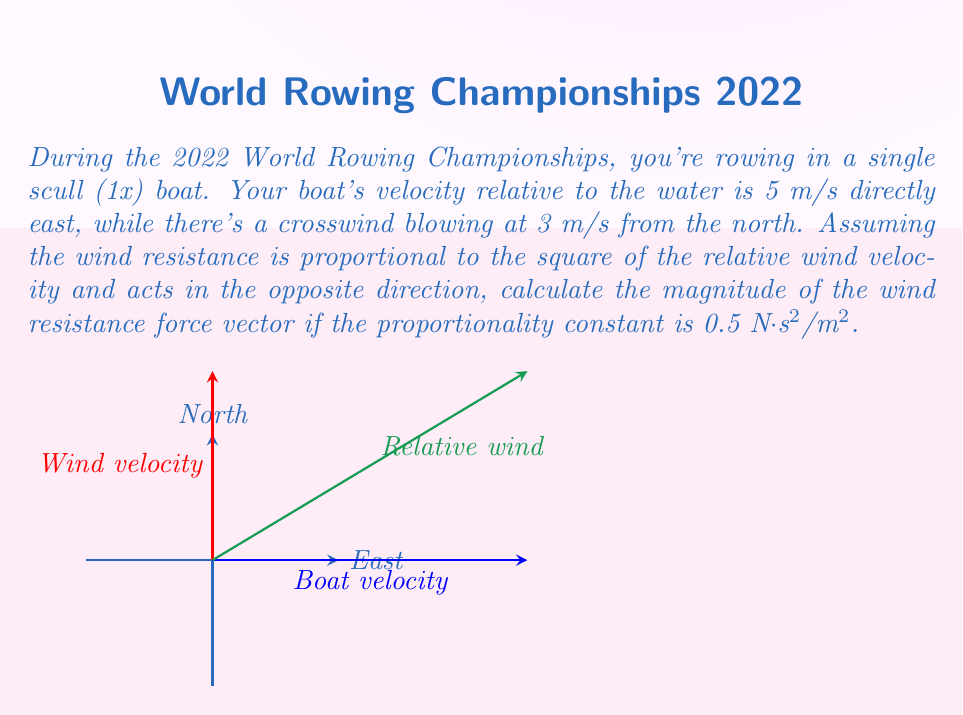Provide a solution to this math problem. Let's approach this step-by-step:

1) First, we need to find the relative wind velocity vector. This is the vector sum of the boat's velocity and the wind velocity:

   $\vec{v}_{rel} = \vec{v}_{boat} + \vec{v}_{wind}$

2) In vector notation:
   $\vec{v}_{rel} = (5\hat{i} + 0\hat{j}) + (0\hat{i} + 3\hat{j}) = 5\hat{i} + 3\hat{j}$

3) The magnitude of this relative wind velocity is:

   $|\vec{v}_{rel}| = \sqrt{5^2 + 3^2} = \sqrt{34}$ m/s

4) The wind resistance force is proportional to the square of this magnitude and acts in the opposite direction. If we call the proportionality constant $k$, then:

   $|\vec{F}_{resistance}| = k|\vec{v}_{rel}|^2 = 0.5 \cdot 34 = 17$ N

5) The direction of this force is opposite to the relative wind velocity, but we only need to calculate the magnitude for this question.
Answer: 17 N 